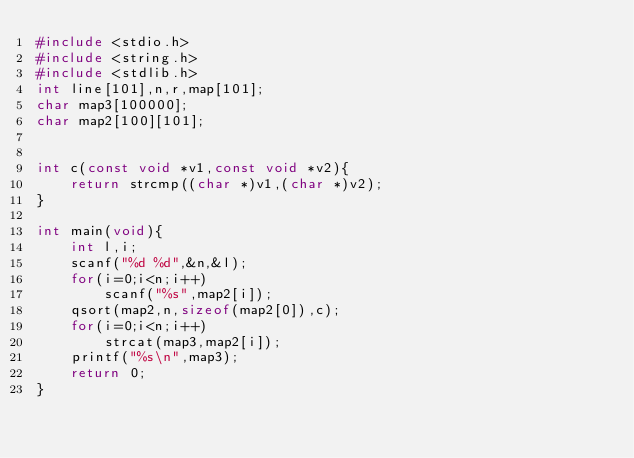<code> <loc_0><loc_0><loc_500><loc_500><_C_>#include <stdio.h>
#include <string.h>
#include <stdlib.h>
int line[101],n,r,map[101];
char map3[100000];
char map2[100][101];


int c(const void *v1,const void *v2){
    return strcmp((char *)v1,(char *)v2);
}

int main(void){
    int l,i;
    scanf("%d %d",&n,&l);
    for(i=0;i<n;i++)
        scanf("%s",map2[i]);
    qsort(map2,n,sizeof(map2[0]),c);
    for(i=0;i<n;i++)
        strcat(map3,map2[i]);
    printf("%s\n",map3);
    return 0;
}

    
</code> 